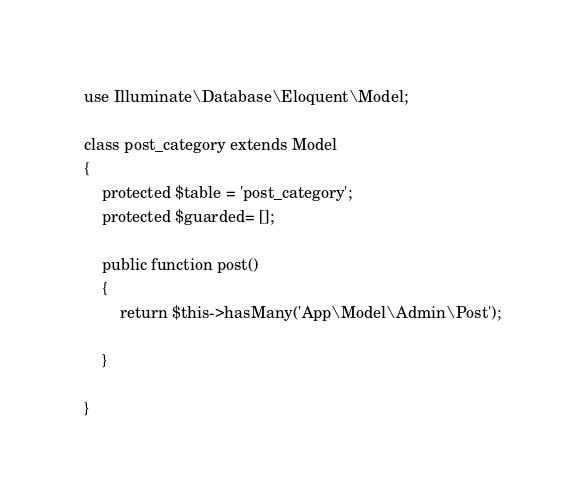<code> <loc_0><loc_0><loc_500><loc_500><_PHP_>
use Illuminate\Database\Eloquent\Model;

class post_category extends Model
{
    protected $table = 'post_category';
    protected $guarded= [];

    public function post()
    {
        return $this->hasMany('App\Model\Admin\Post');
        
    }
    
}
</code> 